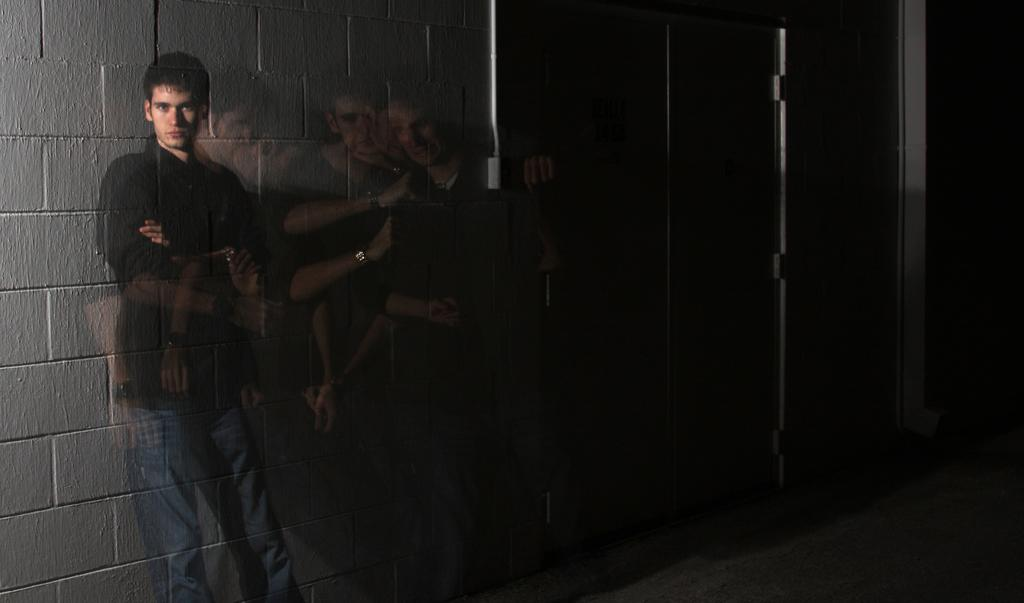Who is the main subject in the image? There is a man in the image. What is the man doing in the image? The man is lying on a wall. What is the man's body position in the image? The man has folded his hands. What can be seen on the right side of the image? There are reflections of the man's image on the right side of the image. What type of lumber is the man using to support himself on the wall? There is no lumber present in the image; the man is lying on a wall without any visible support. What is the man carrying in his hand, and what is it made of? The man is not carrying anything in his hand in the image. 